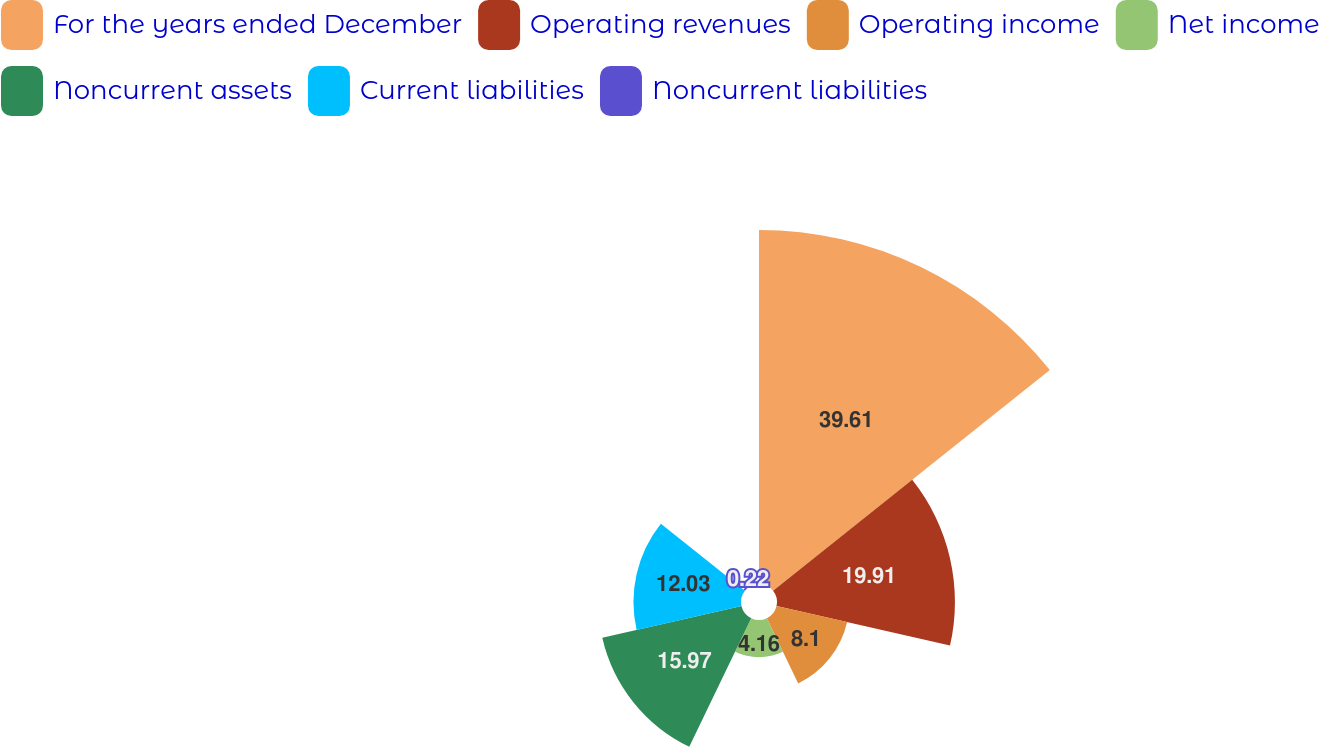<chart> <loc_0><loc_0><loc_500><loc_500><pie_chart><fcel>For the years ended December<fcel>Operating revenues<fcel>Operating income<fcel>Net income<fcel>Noncurrent assets<fcel>Current liabilities<fcel>Noncurrent liabilities<nl><fcel>39.61%<fcel>19.91%<fcel>8.1%<fcel>4.16%<fcel>15.97%<fcel>12.03%<fcel>0.22%<nl></chart> 